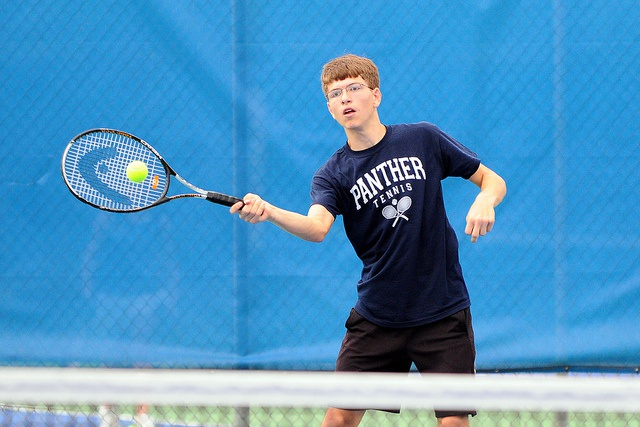Describe the objects in this image and their specific colors. I can see people in teal, black, navy, and tan tones, tennis racket in teal, lightgray, and gray tones, and sports ball in teal, lightyellow, khaki, yellow, and lime tones in this image. 